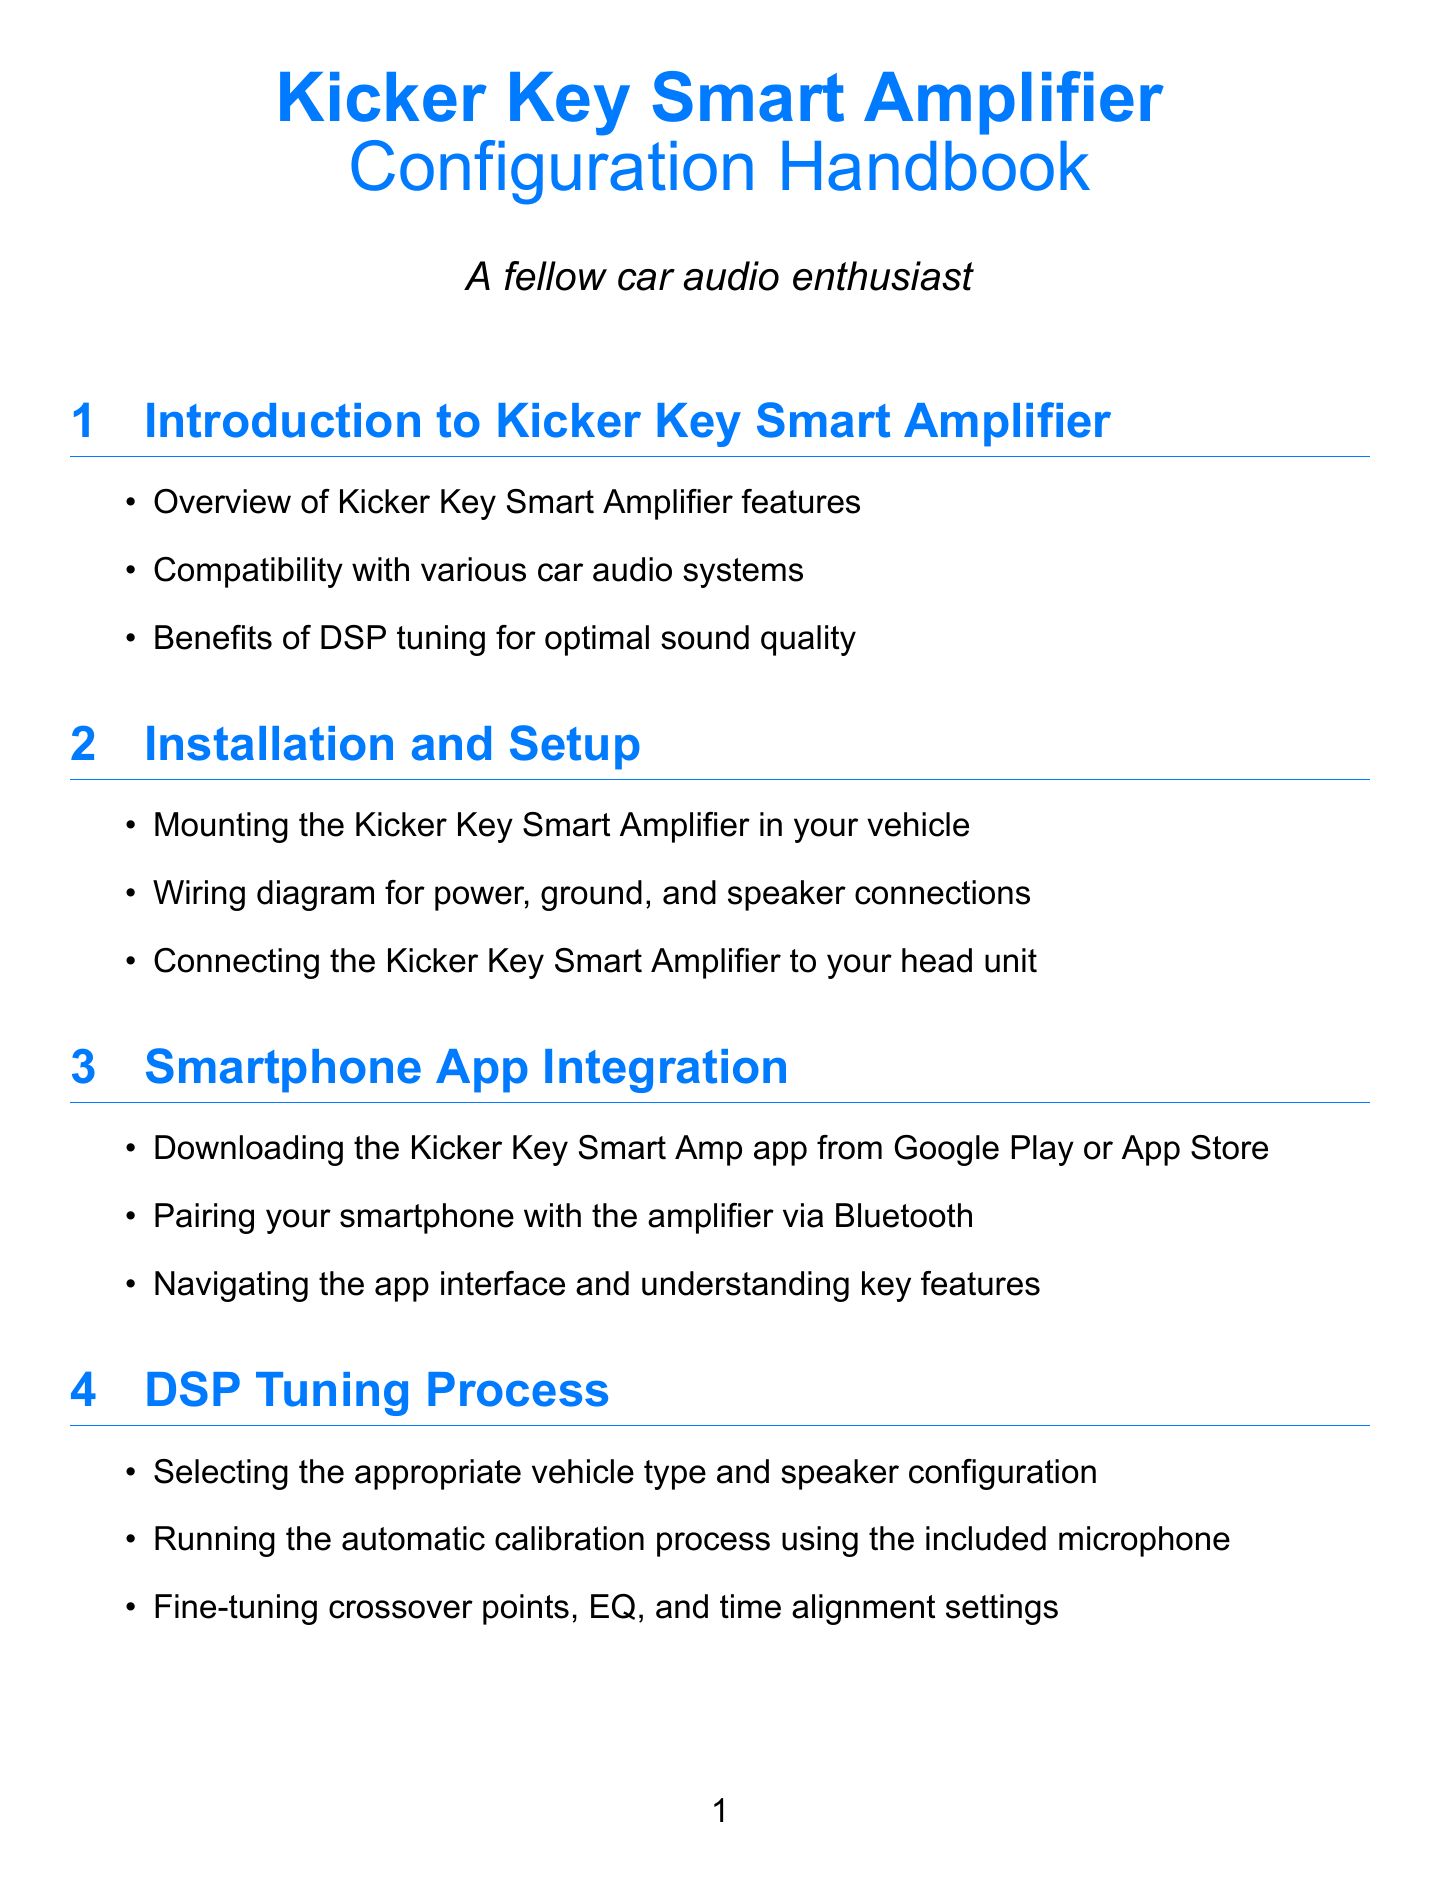What are the features of the Kicker Key Smart Amplifier? The features include an overview of Kicker Key Smart Amplifier features, compatibility with various car audio systems, and benefits of DSP tuning for optimal sound quality.
Answer: Features include overview, compatibility, benefits of DSP tuning What is the main purpose of the Kicker Key Smart Amp app? The main purpose of the app is to facilitate smartphone app integration with the amplifier, including downloading, pairing, and navigating the app.
Answer: Smartphone integration with the amplifier What is one of the automatic calibration steps? One of the steps is running the automatic calibration process using the included microphone.
Answer: Running automatic calibration using the microphone Where should the microphone be placed for best results? The recommended placement is at ear level in the driver's seat for optimizing DSP tuning.
Answer: Ear level in the driver's seat What vehicle model is mentioned in the personal experiences section? The vehicle model mentioned is a 2018 Toyota Camry in which the amplifier was installed.
Answer: 2018 Toyota Camry What is a recommended action regarding firmware? It is recommended to check for firmware updates in the Kicker Key Smart Amp app regularly.
Answer: Check for firmware updates regularly How does the author describe the sound quality after tuning? The sound quality is described as improved with more precise imaging and tightened bass response.
Answer: Improved sound quality with precise imaging and tightened bass What should you experiment with after automatic calibration? You should experiment with time alignment settings after the automatic calibration.
Answer: Time alignment settings 